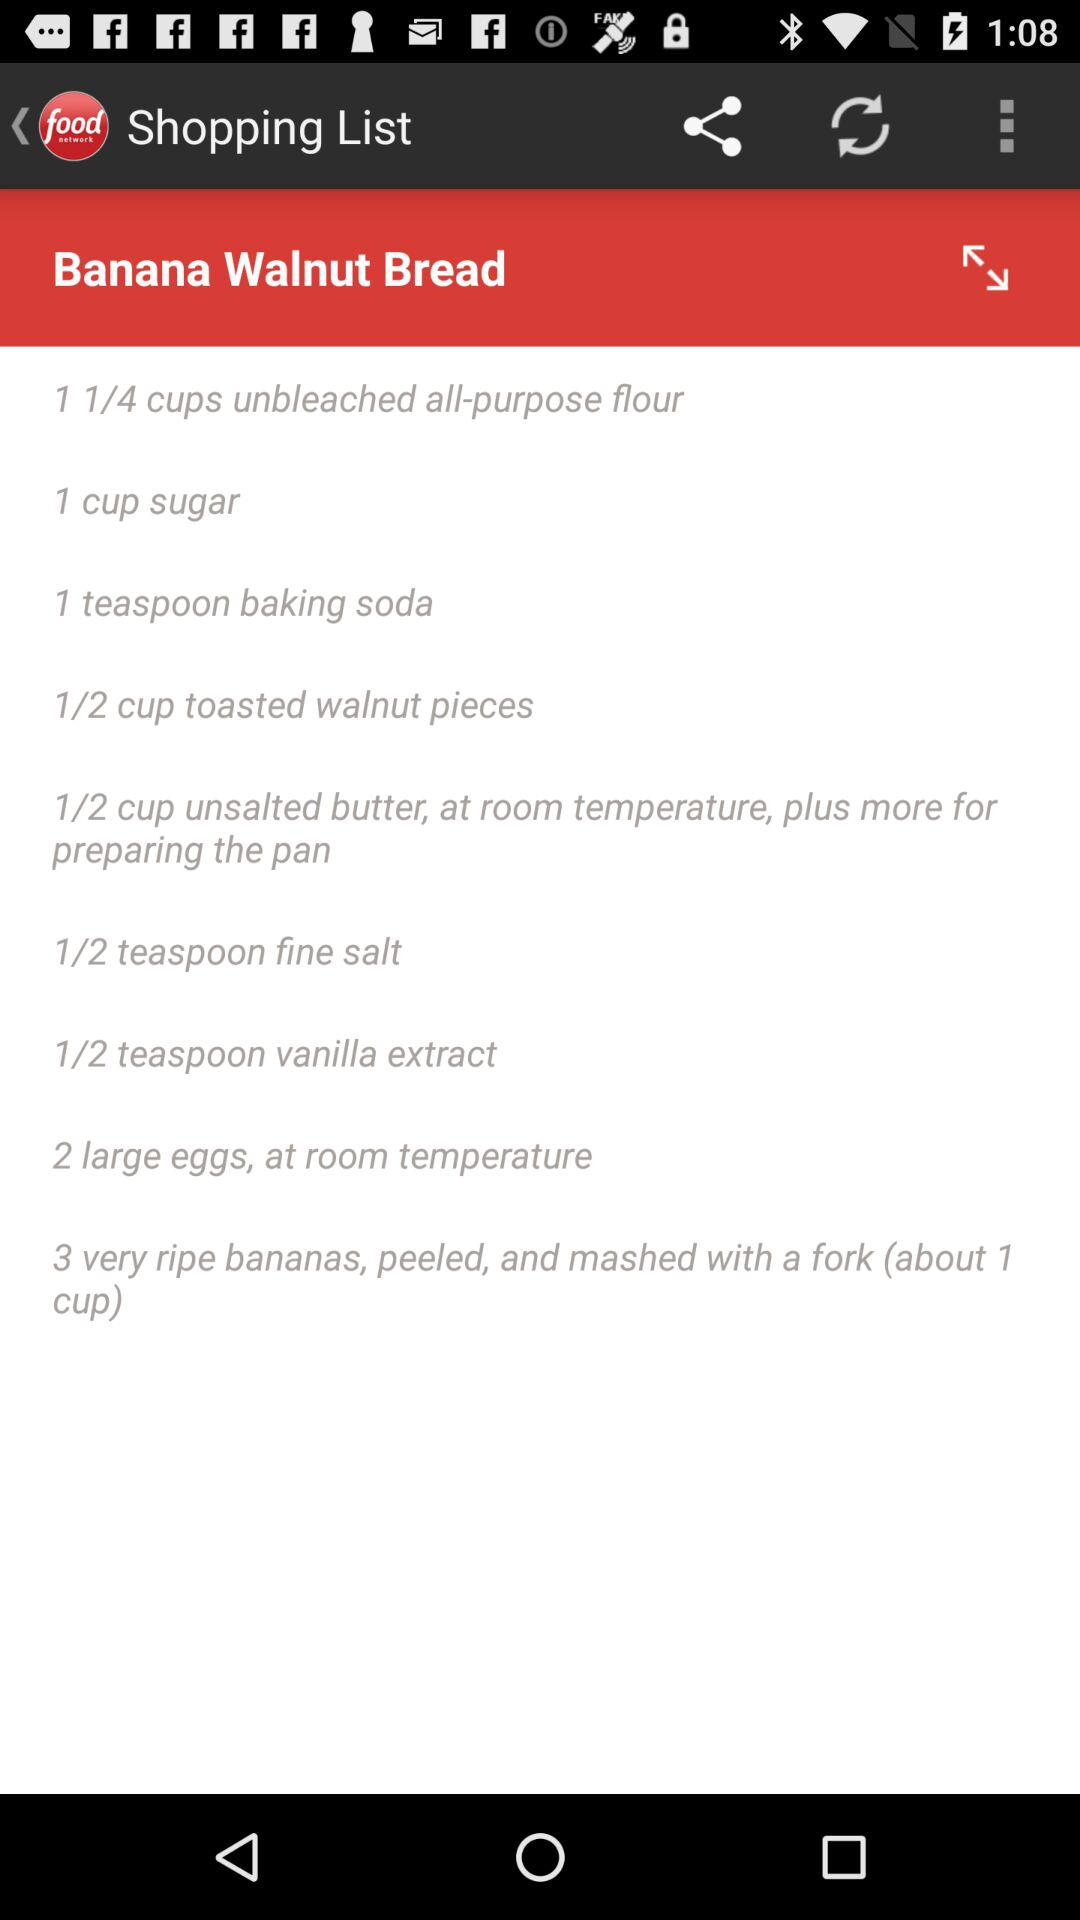How many eggs are required? The required number of eggs is 2. 